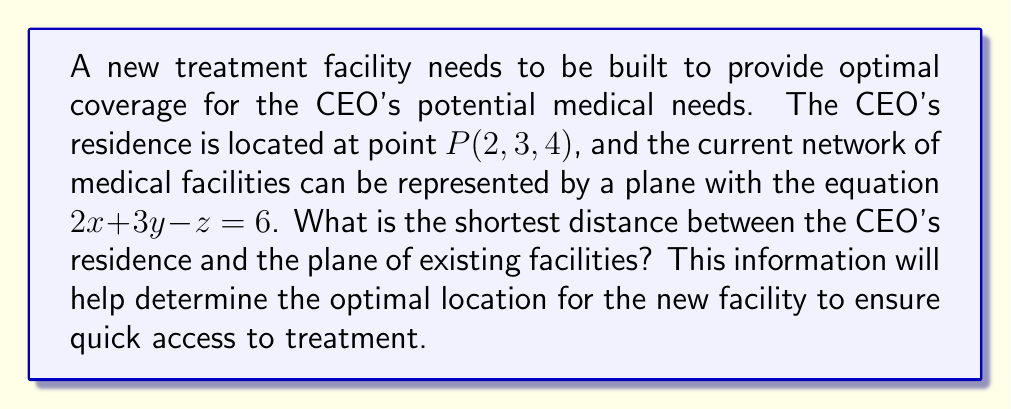Help me with this question. To find the shortest distance between a point and a plane in 3D space, we can use the formula:

$$d = \frac{|Ax_0 + By_0 + Cz_0 + D|}{\sqrt{A^2 + B^2 + C^2}}$$

Where $(x_0, y_0, z_0)$ is the point, and $Ax + By + Cz + D = 0$ is the equation of the plane.

Step 1: Identify the components from the given information:
- Point $P(x_0, y_0, z_0) = (2, 3, 4)$
- Plane equation: $2x + 3y - z = 6$, which can be rewritten as $2x + 3y - z - 6 = 0$

Step 2: Match the plane equation to the standard form $Ax + By + Cz + D = 0$:
$A = 2$, $B = 3$, $C = -1$, $D = -6$

Step 3: Substitute the values into the distance formula:

$$d = \frac{|2(2) + 3(3) + (-1)(4) + (-6)|}{\sqrt{2^2 + 3^2 + (-1)^2}}$$

Step 4: Simplify the numerator:
$$d = \frac{|4 + 9 - 4 - 6|}{\sqrt{4 + 9 + 1}}$$
$$d = \frac{|3|}{\sqrt{14}}$$

Step 5: Simplify the final expression:
$$d = \frac{3}{\sqrt{14}}$$

This distance represents the shortest path from the CEO's residence to the plane of existing facilities, which will help determine the optimal location for the new treatment facility.
Answer: $\frac{3}{\sqrt{14}}$ 